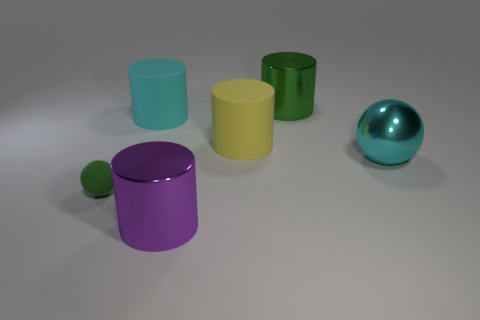Subtract 1 cylinders. How many cylinders are left? 3 Add 1 small blue metal cylinders. How many objects exist? 7 Subtract all brown cylinders. Subtract all gray spheres. How many cylinders are left? 4 Subtract all cylinders. How many objects are left? 2 Add 2 tiny objects. How many tiny objects are left? 3 Add 6 large matte cylinders. How many large matte cylinders exist? 8 Subtract 0 brown spheres. How many objects are left? 6 Subtract all cyan objects. Subtract all cyan rubber objects. How many objects are left? 3 